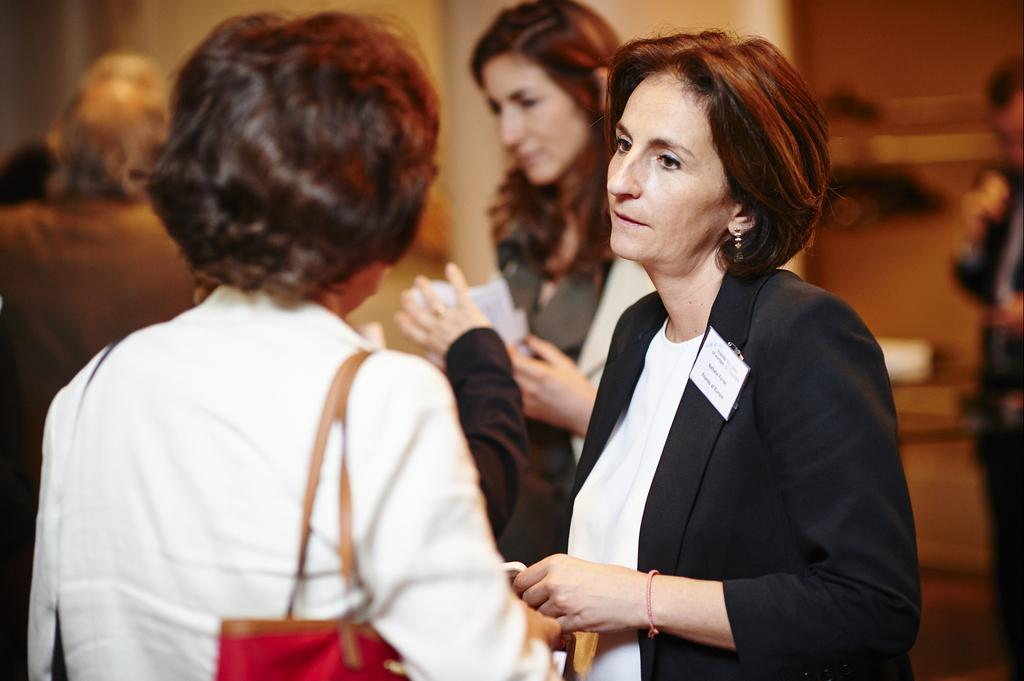Where was the image taken? The image was taken indoors. What are the two main subjects in the image? Two women are standing in the middle of the image. What are the women doing in the image? The women are talking to each other. What is the women standing on? The women are standing on the floor. Can you describe the background of the image? There are a few people in the background of the image, and there is a wall visible. What is the rate of the women's conversation in the image? There is no information about the rate of the women's conversation in the image. How many legs does the floor have in the image? The floor does not have legs; it is a flat surface for the women to stand on. 